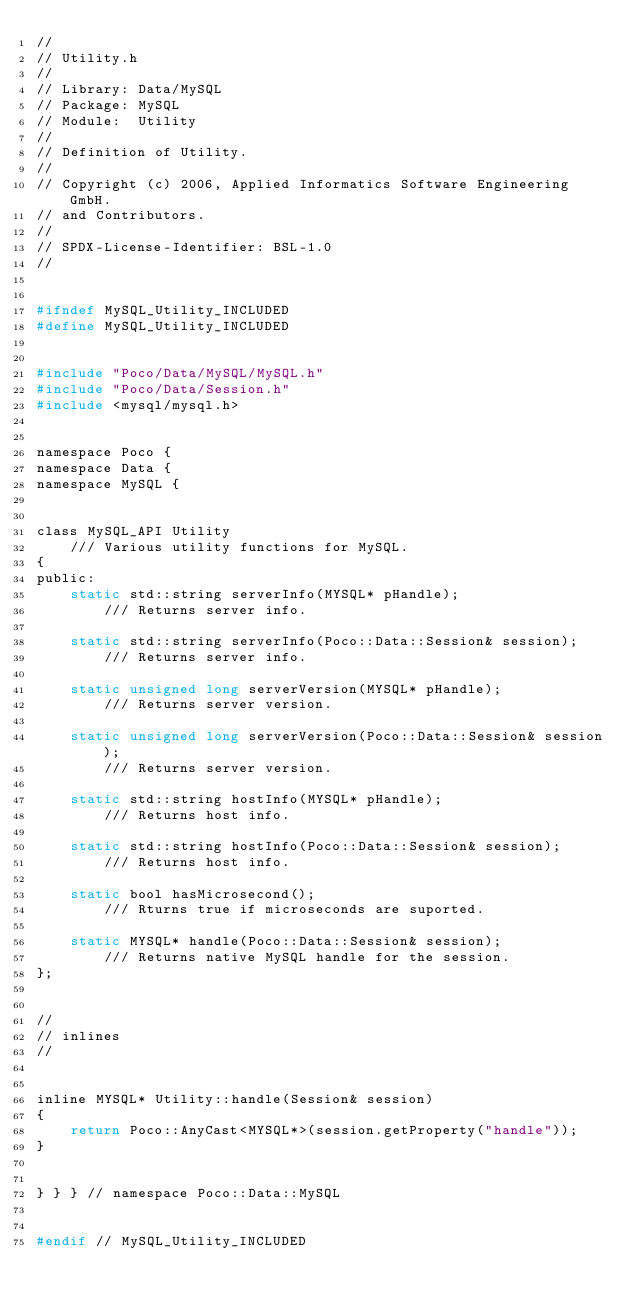<code> <loc_0><loc_0><loc_500><loc_500><_C_>//
// Utility.h
//
// Library: Data/MySQL
// Package: MySQL
// Module:  Utility
//
// Definition of Utility.
//
// Copyright (c) 2006, Applied Informatics Software Engineering GmbH.
// and Contributors.
//
// SPDX-License-Identifier:	BSL-1.0
//


#ifndef MySQL_Utility_INCLUDED
#define MySQL_Utility_INCLUDED


#include "Poco/Data/MySQL/MySQL.h"
#include "Poco/Data/Session.h"
#include <mysql/mysql.h>


namespace Poco {
namespace Data {
namespace MySQL {


class MySQL_API Utility
	/// Various utility functions for MySQL.
{
public:
	static std::string serverInfo(MYSQL* pHandle);
		/// Returns server info.

	static std::string serverInfo(Poco::Data::Session& session);
		/// Returns server info.

	static unsigned long serverVersion(MYSQL* pHandle);
		/// Returns server version.

	static unsigned long serverVersion(Poco::Data::Session& session);
		/// Returns server version.

	static std::string hostInfo(MYSQL* pHandle);
		/// Returns host info.

	static std::string hostInfo(Poco::Data::Session& session);
		/// Returns host info.

	static bool hasMicrosecond();
		/// Rturns true if microseconds are suported.

	static MYSQL* handle(Poco::Data::Session& session);
		/// Returns native MySQL handle for the session.
};


//
// inlines
//


inline MYSQL* Utility::handle(Session& session)
{
	return Poco::AnyCast<MYSQL*>(session.getProperty("handle"));
}


} } } // namespace Poco::Data::MySQL


#endif // MySQL_Utility_INCLUDED
</code> 